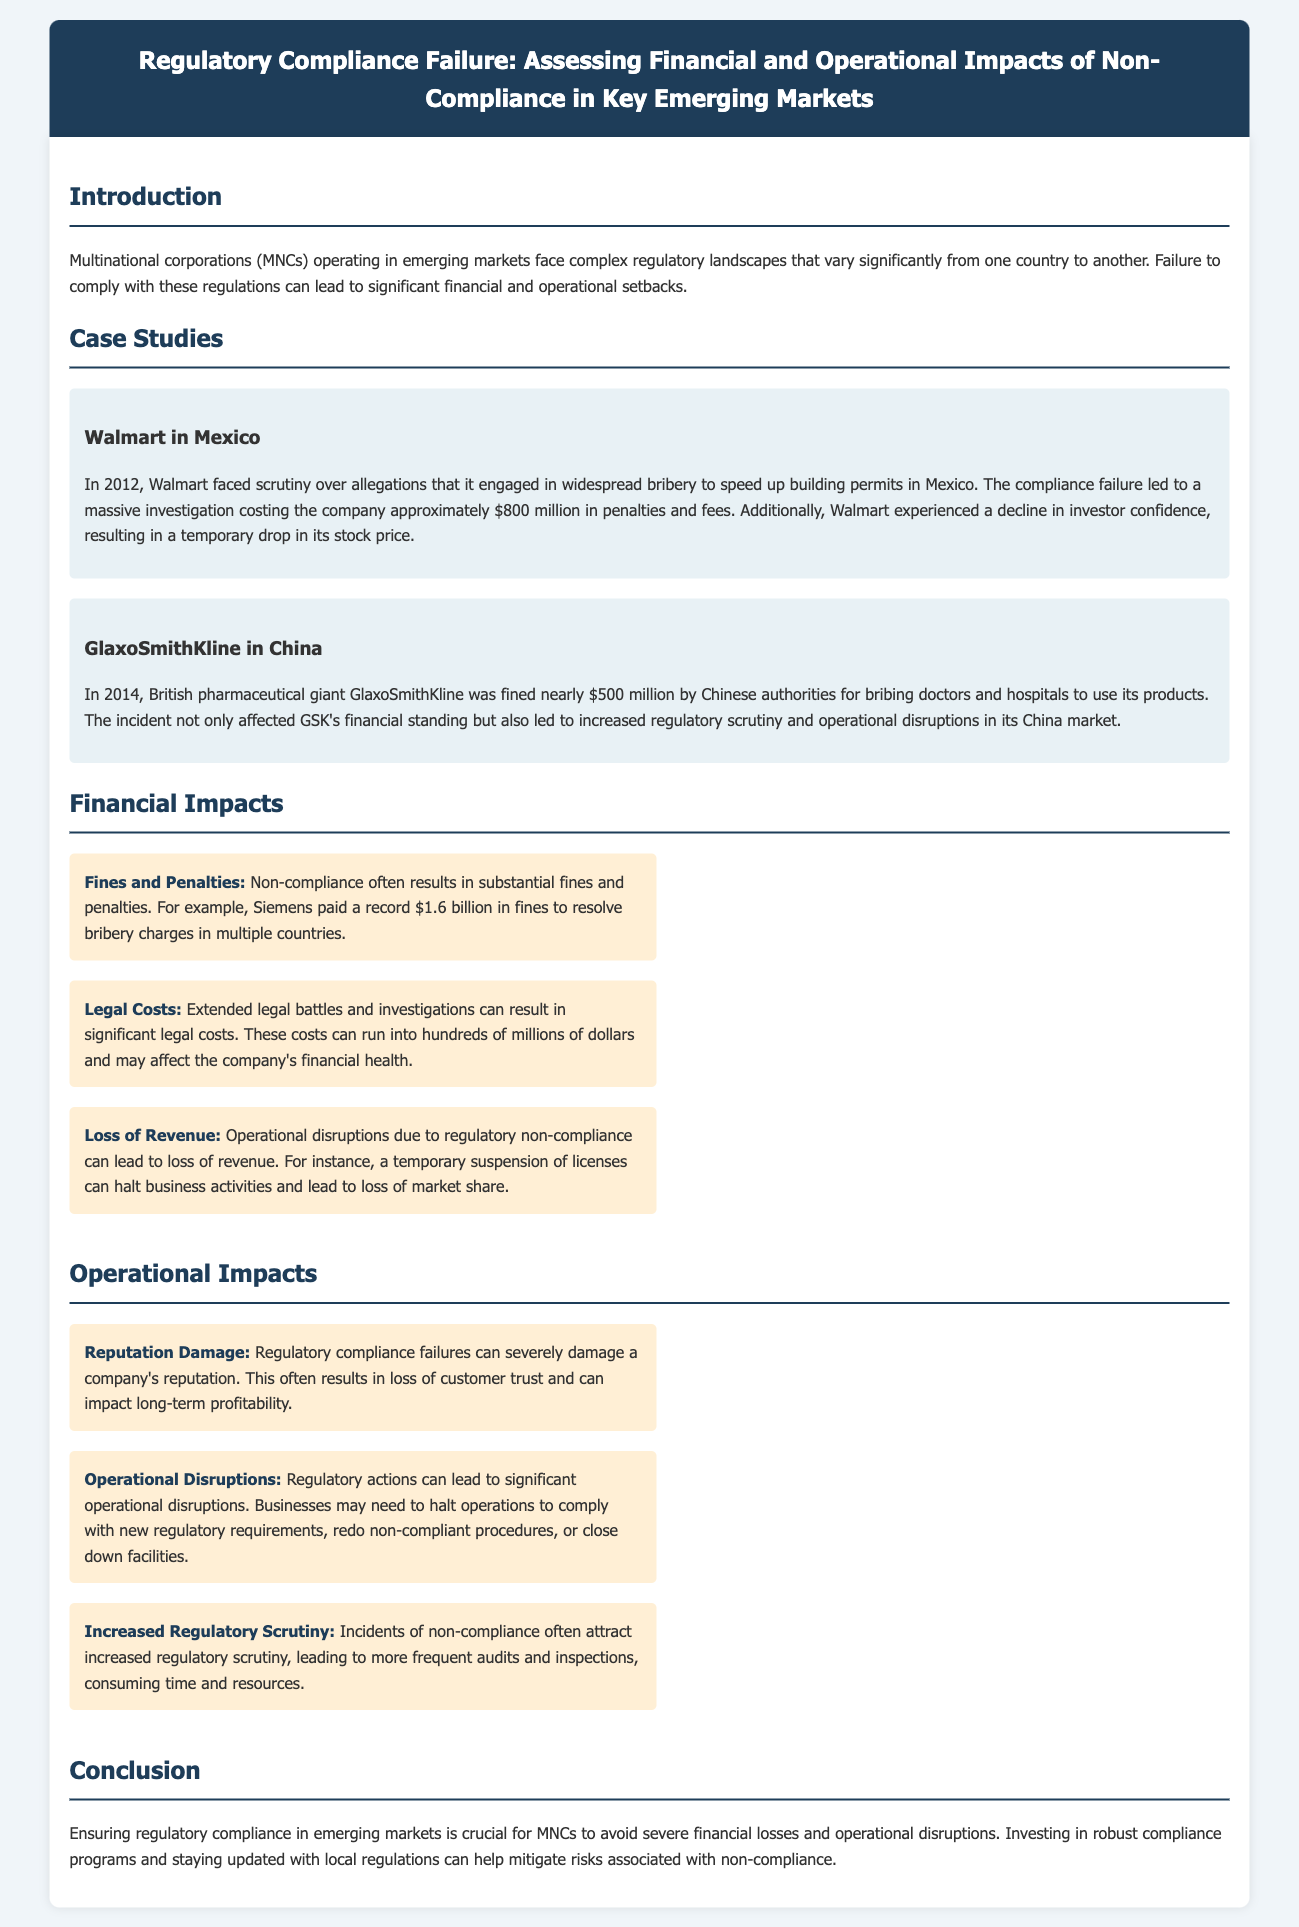what was the fine amount for Walmart in Mexico? The document states that Walmart faced approximately $800 million in penalties and fees for its compliance failure in Mexico.
Answer: $800 million what incident occurred with GlaxoSmithKline in China? The document describes that GlaxoSmithKline was fined nearly $500 million for bribing doctors and hospitals in China.
Answer: bribing doctors and hospitals what year did the Walmart incident happen? According to the document, the incident involving Walmart in Mexico took place in 2012.
Answer: 2012 what is a financial impact of non-compliance mentioned in the report? The report lists fines and penalties as a financial impact of non-compliance, exemplified by Siemens paying a record fine.
Answer: fines and penalties what operational impact does regulatory compliance failure have on companies? The document mentions reputation damage as a key operational impact of regulatory compliance failures.
Answer: reputation damage how much was GlaxoSmithKline fined by Chinese authorities? The document states that GlaxoSmithKline was fined nearly $500 million by Chinese authorities.
Answer: nearly $500 million what does increased regulatory scrutiny lead to? The text notes that increased regulatory scrutiny leads to more frequent audits and inspections.
Answer: more frequent audits and inspections what is the conclusion regarding regulatory compliance in emerging markets? The document concludes that ensuring regulatory compliance is crucial for MNCs to avoid financial losses and operational disruptions.
Answer: crucial for MNCs to avoid financial losses and operational disruptions 